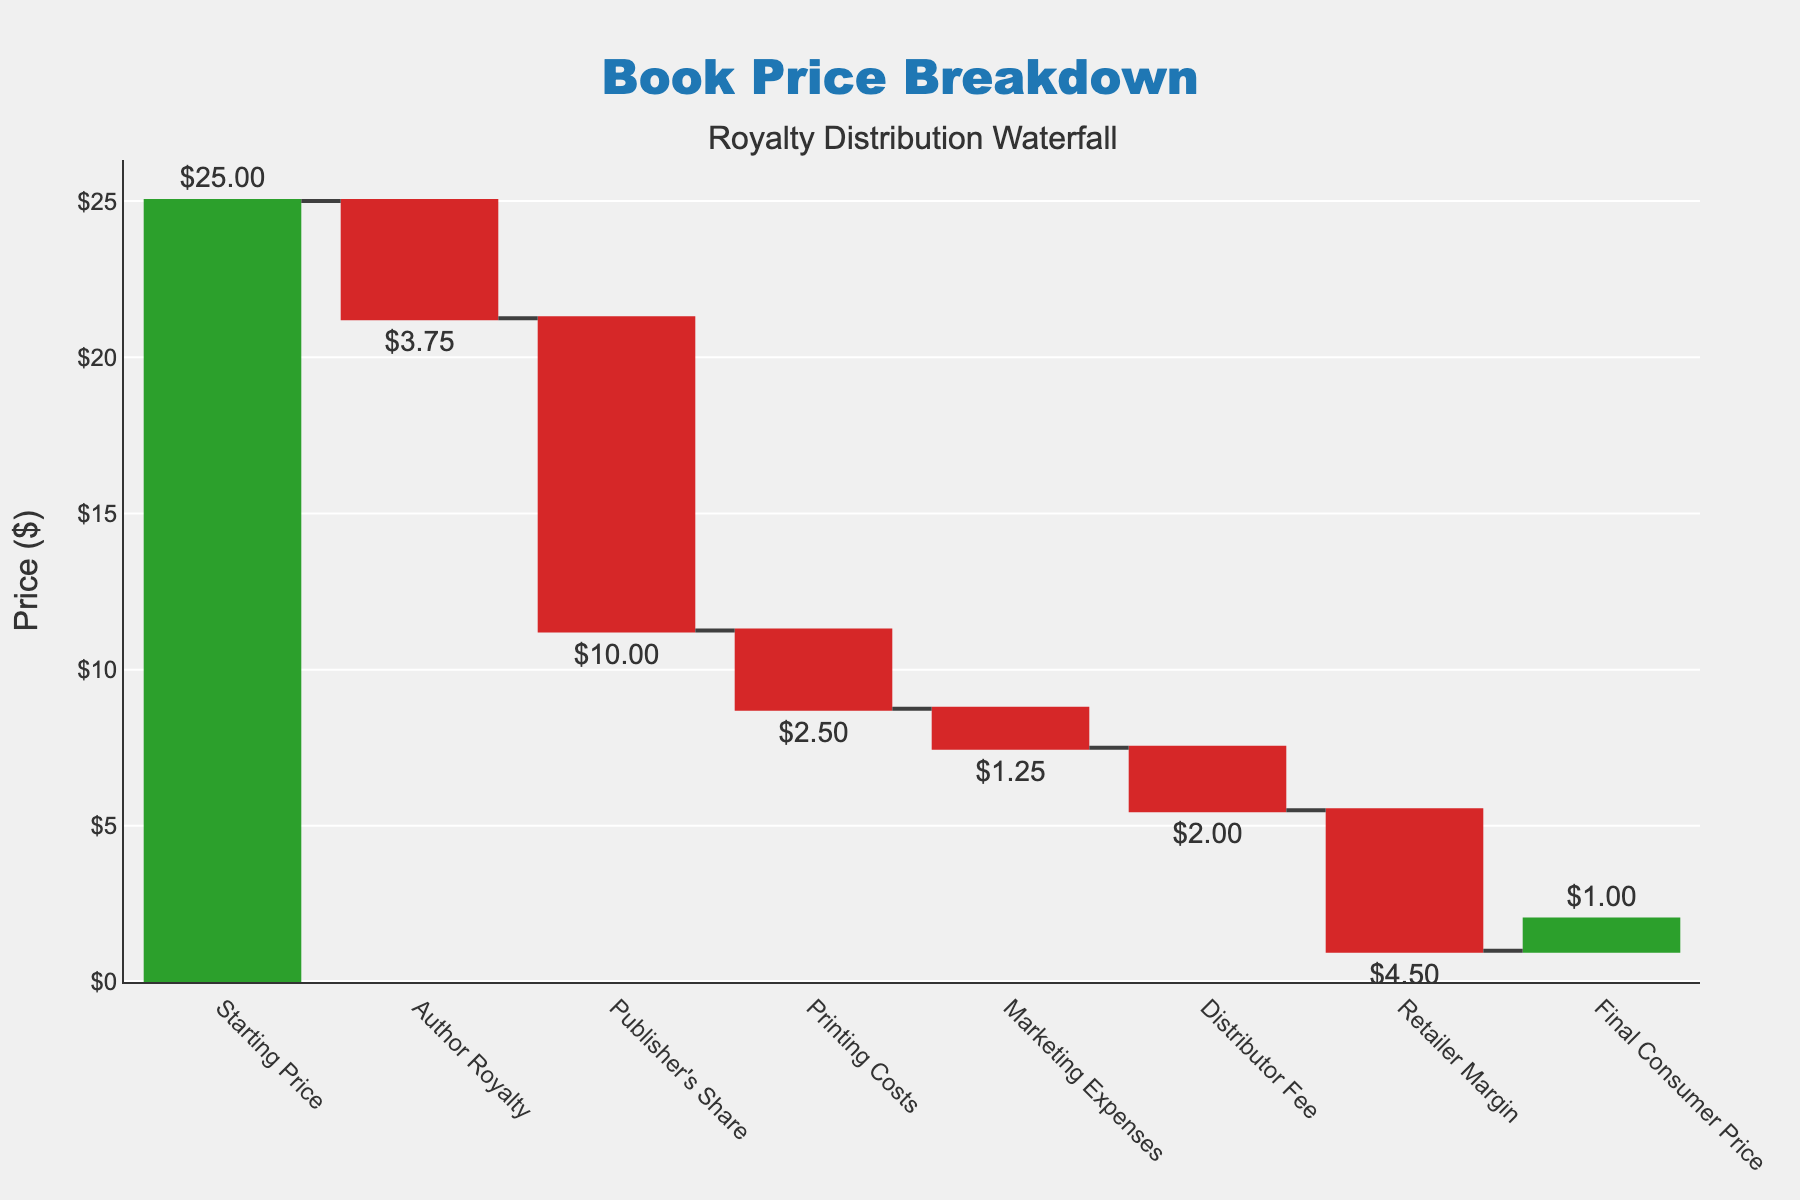What is the title of the figure? The title is displayed at the top-center of the figure. It reads "Book Price Breakdown".
Answer: Book Price Breakdown How much is the initial starting price? The first bar on the chart is labeled "Starting Price" and its value is $25.00.
Answer: $25.00 How much does the author receive in royalties? The bar labeled "Author Royalty" shows a negative value of $3.75. This indicates that $3.75 is deducted from the starting price as the author's royalty.
Answer: $3.75 What is the final consumer price? The last bar on the chart is labeled "Final Consumer Price" and its value is $1.00.
Answer: $1.00 Which category has the highest deduction value? By comparing the negative values of each category, "Publisher's Share" has the highest deduction with a value of $10.00.
Answer: Publisher's Share What is the total amount deducted for printing and marketing expenses combined? Printing Costs are $2.50 and Marketing Expenses are $1.25. Adding these together: $2.50 + $1.25 = $3.75.
Answer: $3.75 Which costs more: the distributor fee or the retailer margin? By comparing the values, Distributor Fee is $2.00, and Retailer Margin is $4.50. The retailer margin costs more.
Answer: Retailer Margin What is the difference between the publisher's share and the printing costs? The Publisher's Share is $10.00 and Printing Costs are $2.50. The difference is $10.00 - $2.50 = $7.50.
Answer: $7.50 How much does the total deduction equal before reaching the final consumer price? Summing all the deductions: $3.75 (Author Royalty) + $10.00 (Publisher's Share) + $2.50 (Printing Costs) + $1.25 (Marketing Expenses) + $2.00 (Distributor Fee) + $4.50 (Retailer Margin) = $24.00.
Answer: $24.00 What color represents increasing values in the chart? The colors are specified in the figure with green representing increasing values.
Answer: Green 